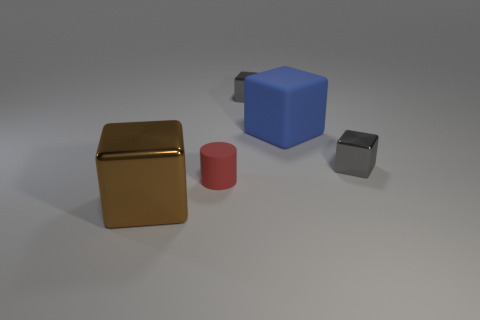Add 2 red cylinders. How many objects exist? 7 Subtract all cylinders. How many objects are left? 4 Subtract 0 purple balls. How many objects are left? 5 Subtract all red rubber blocks. Subtract all big brown metal objects. How many objects are left? 4 Add 4 rubber cylinders. How many rubber cylinders are left? 5 Add 4 large gray shiny spheres. How many large gray shiny spheres exist? 4 